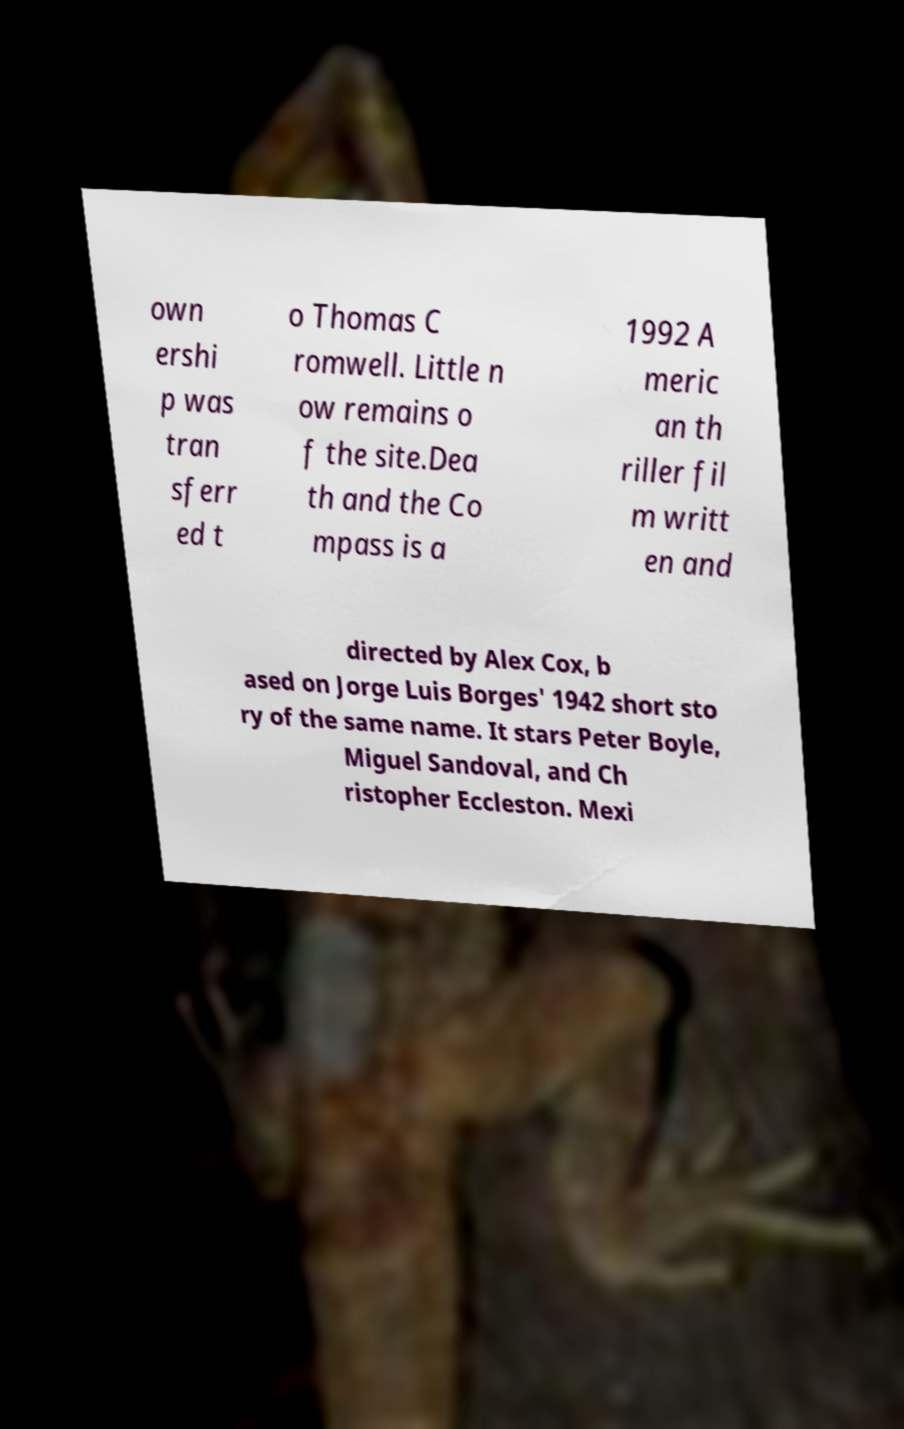Please read and relay the text visible in this image. What does it say? own ershi p was tran sferr ed t o Thomas C romwell. Little n ow remains o f the site.Dea th and the Co mpass is a 1992 A meric an th riller fil m writt en and directed by Alex Cox, b ased on Jorge Luis Borges' 1942 short sto ry of the same name. It stars Peter Boyle, Miguel Sandoval, and Ch ristopher Eccleston. Mexi 